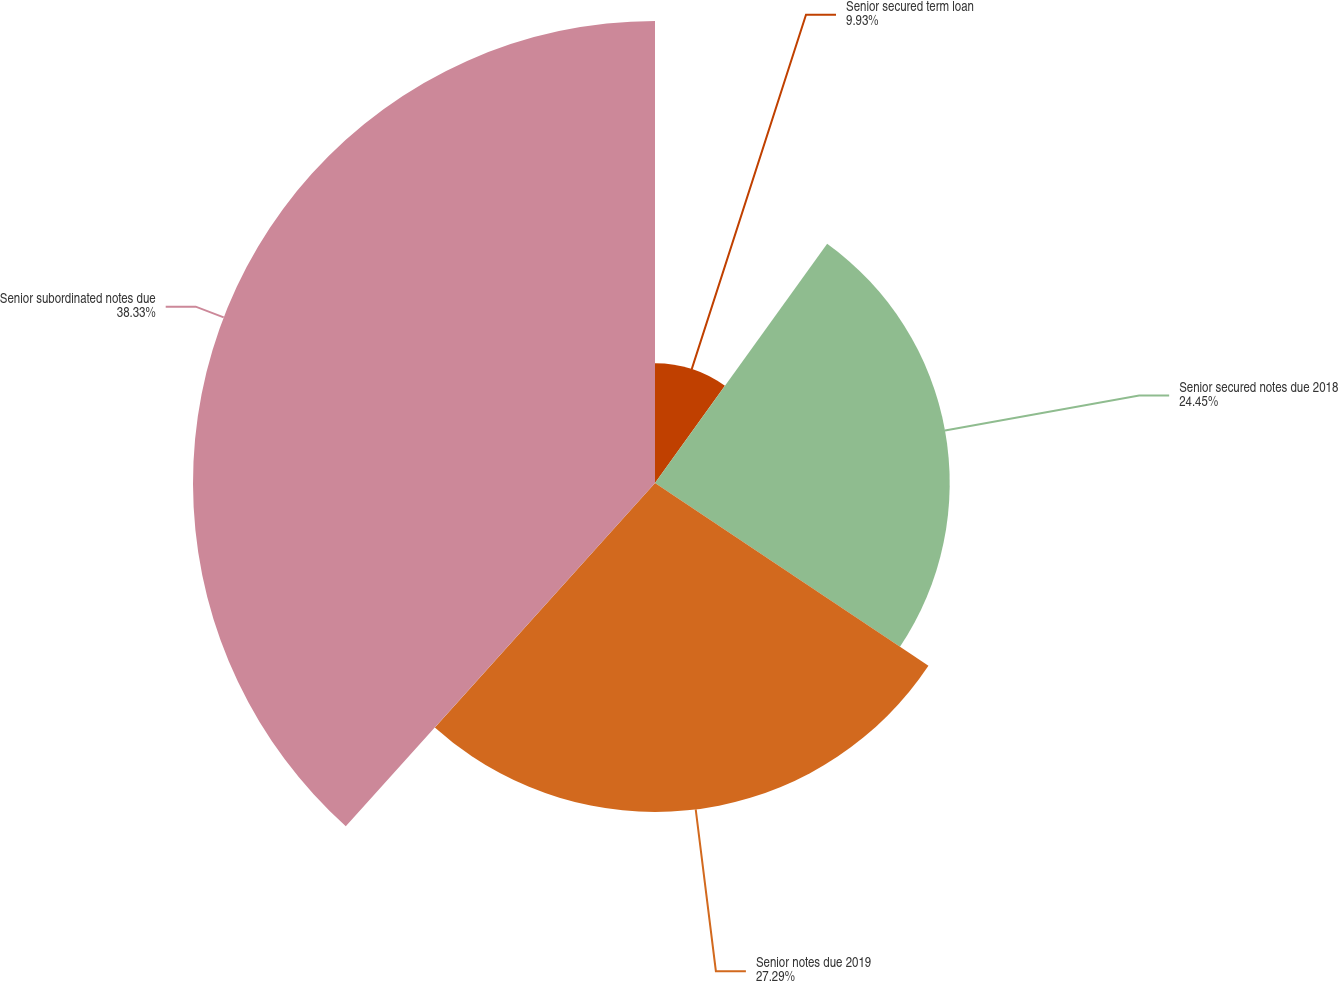Convert chart to OTSL. <chart><loc_0><loc_0><loc_500><loc_500><pie_chart><fcel>Senior secured term loan<fcel>Senior secured notes due 2018<fcel>Senior notes due 2019<fcel>Senior subordinated notes due<nl><fcel>9.93%<fcel>24.45%<fcel>27.29%<fcel>38.33%<nl></chart> 